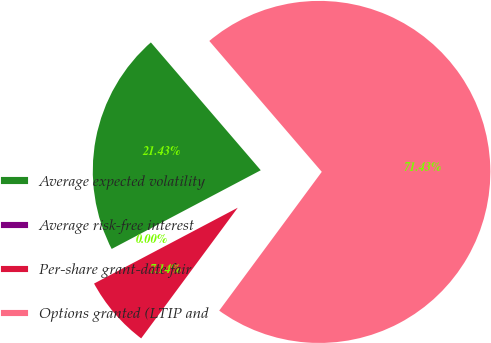Convert chart. <chart><loc_0><loc_0><loc_500><loc_500><pie_chart><fcel>Average expected volatility<fcel>Average risk-free interest<fcel>Per-share grant-date fair<fcel>Options granted (LTIP and<nl><fcel>21.43%<fcel>0.0%<fcel>7.14%<fcel>71.43%<nl></chart> 